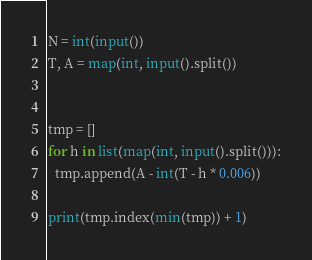<code> <loc_0><loc_0><loc_500><loc_500><_Python_>N = int(input())
T, A = map(int, input().split())


tmp = []
for h in list(map(int, input().split())):
  tmp.append(A - int(T - h * 0.006))

print(tmp.index(min(tmp)) + 1)</code> 